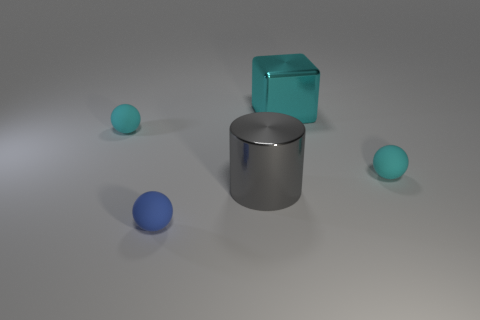What size is the cyan ball left of the small cyan sphere that is on the right side of the small sphere in front of the gray metal cylinder?
Offer a terse response. Small. There is a tiny object right of the large metallic cube; is it the same shape as the blue thing?
Ensure brevity in your answer.  Yes. Do the tiny ball right of the gray metal thing and the shiny block have the same color?
Your response must be concise. Yes. Is there any other thing of the same color as the large shiny block?
Ensure brevity in your answer.  Yes. Is the shiny block the same size as the blue rubber sphere?
Ensure brevity in your answer.  No. What number of other small things are the same shape as the blue thing?
Offer a terse response. 2. The cylinder that is the same size as the shiny cube is what color?
Provide a short and direct response. Gray. Is there a purple rubber cylinder?
Offer a terse response. No. There is a tiny cyan rubber object that is on the right side of the big cylinder; what is its shape?
Keep it short and to the point. Sphere. What number of rubber balls are both behind the cylinder and on the left side of the big gray object?
Keep it short and to the point. 1. 